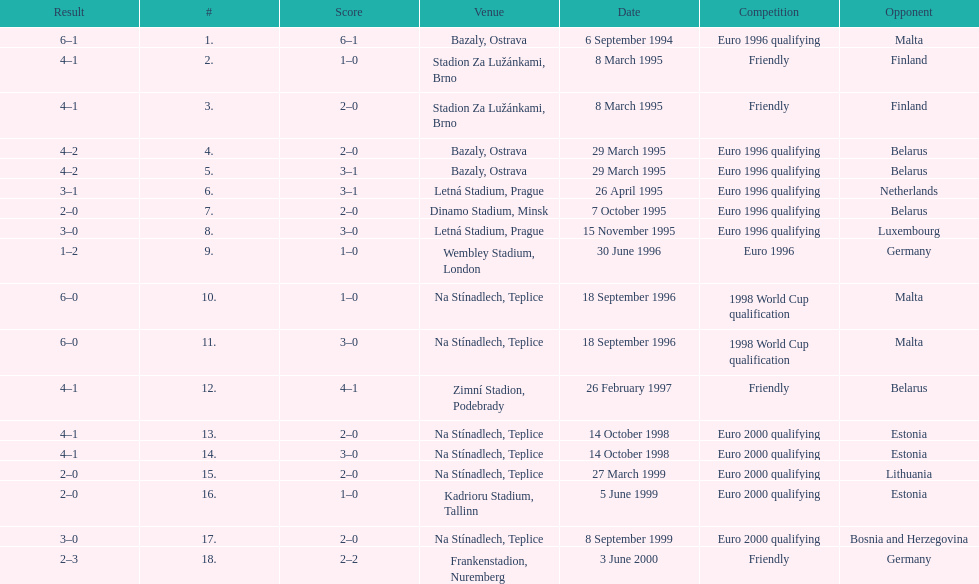How many games took place in ostrava? 2. 